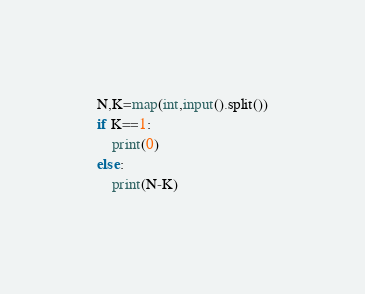Convert code to text. <code><loc_0><loc_0><loc_500><loc_500><_Python_>N,K=map(int,input().split())
if K==1:
    print(0)
else:
    print(N-K)</code> 